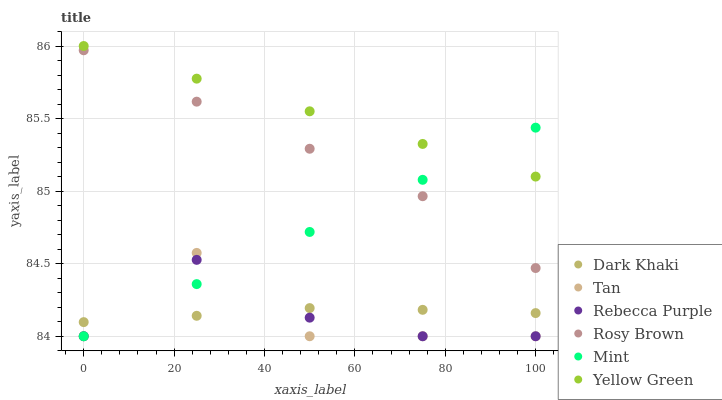Does Tan have the minimum area under the curve?
Answer yes or no. Yes. Does Yellow Green have the maximum area under the curve?
Answer yes or no. Yes. Does Rosy Brown have the minimum area under the curve?
Answer yes or no. No. Does Rosy Brown have the maximum area under the curve?
Answer yes or no. No. Is Mint the smoothest?
Answer yes or no. Yes. Is Tan the roughest?
Answer yes or no. Yes. Is Rosy Brown the smoothest?
Answer yes or no. No. Is Rosy Brown the roughest?
Answer yes or no. No. Does Rebecca Purple have the lowest value?
Answer yes or no. Yes. Does Rosy Brown have the lowest value?
Answer yes or no. No. Does Yellow Green have the highest value?
Answer yes or no. Yes. Does Rosy Brown have the highest value?
Answer yes or no. No. Is Tan less than Rosy Brown?
Answer yes or no. Yes. Is Yellow Green greater than Rebecca Purple?
Answer yes or no. Yes. Does Rebecca Purple intersect Tan?
Answer yes or no. Yes. Is Rebecca Purple less than Tan?
Answer yes or no. No. Is Rebecca Purple greater than Tan?
Answer yes or no. No. Does Tan intersect Rosy Brown?
Answer yes or no. No. 